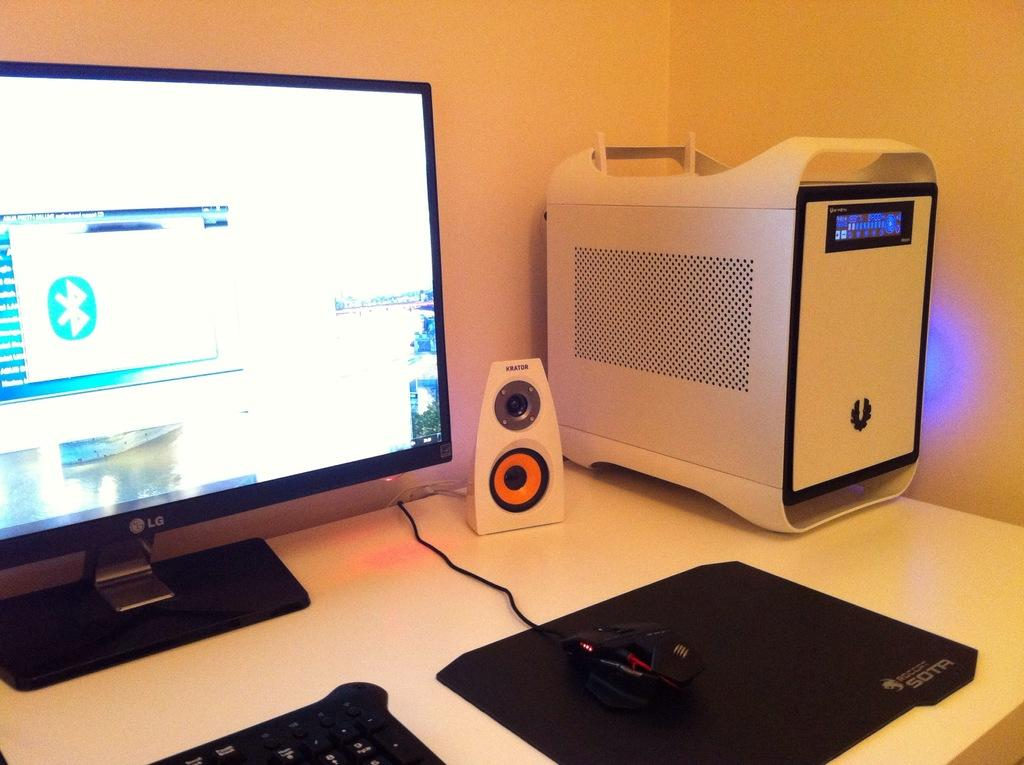<image>
Render a clear and concise summary of the photo. An LG monitor and Krator speakers next to a tower computer ona desk. 